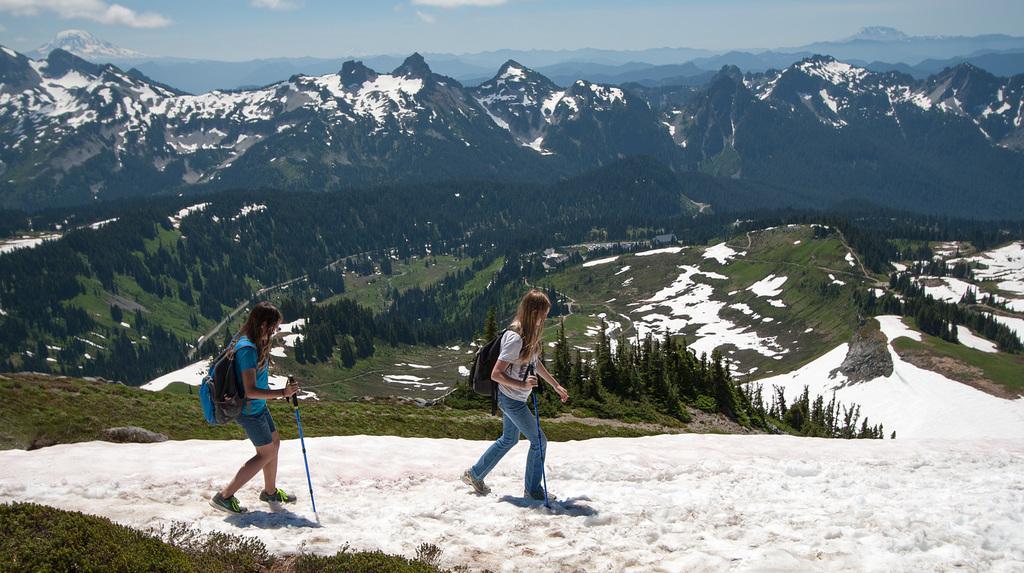In one or two sentences, can you explain what this image depicts? In this image I can see few mountains, few trees, snow and two people are walking. They are holding sticks and wearing bags. The sky is in blue and white color. 